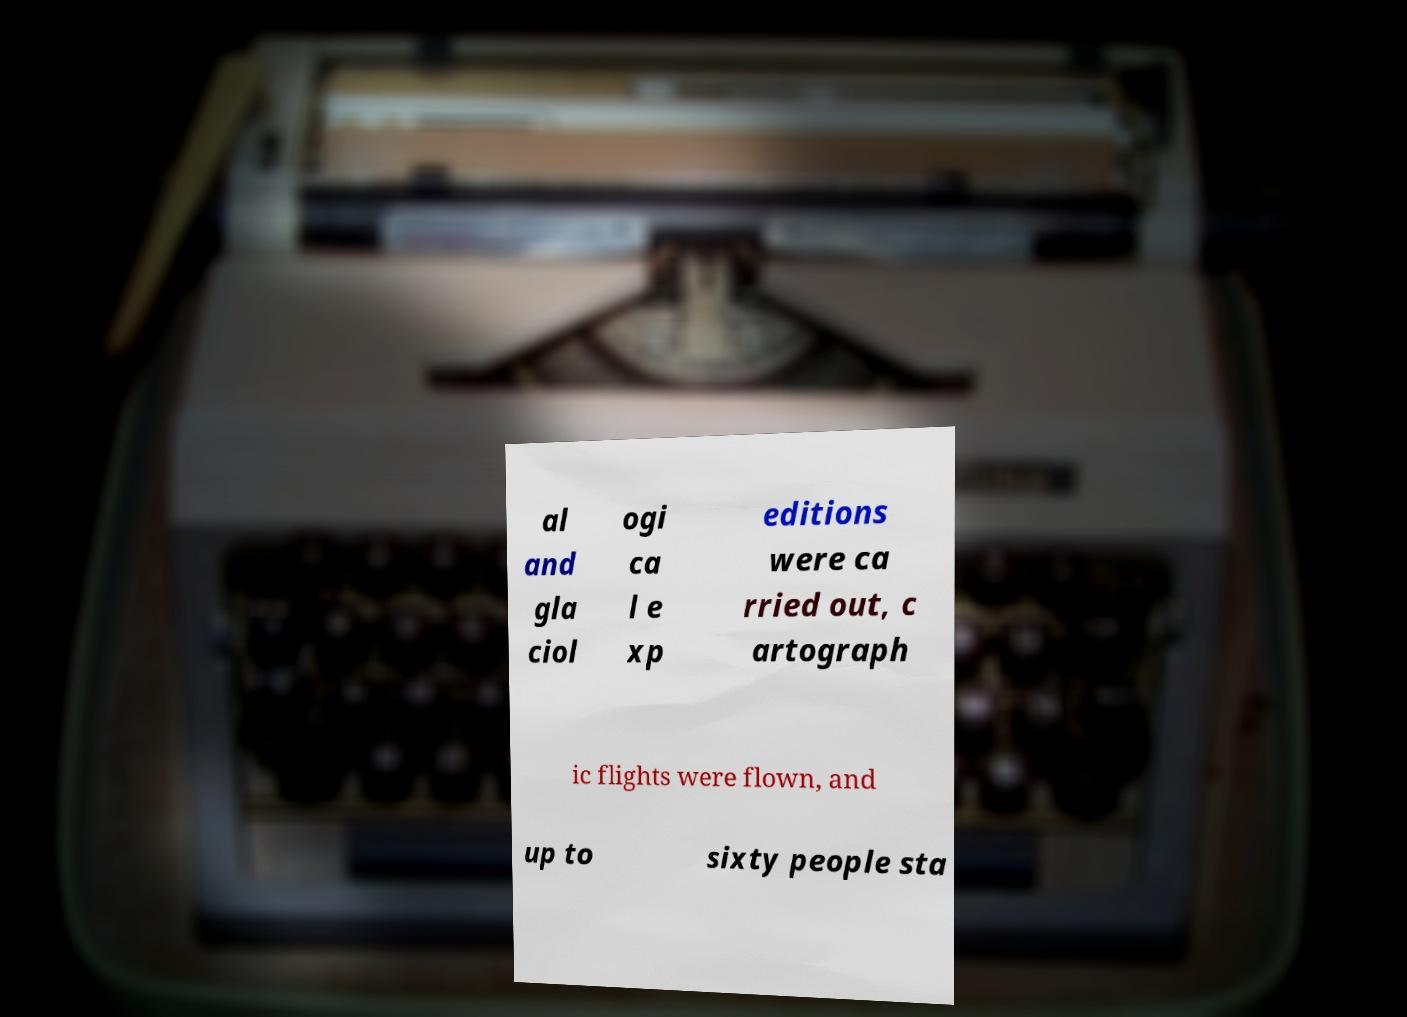Please read and relay the text visible in this image. What does it say? al and gla ciol ogi ca l e xp editions were ca rried out, c artograph ic flights were flown, and up to sixty people sta 